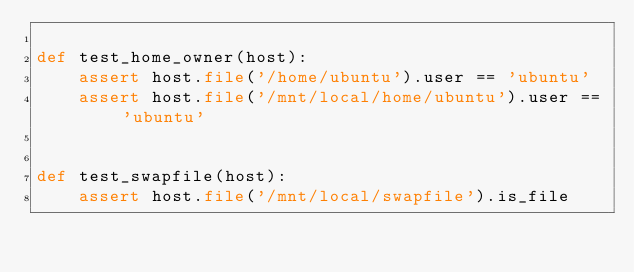Convert code to text. <code><loc_0><loc_0><loc_500><loc_500><_Python_>
def test_home_owner(host):
    assert host.file('/home/ubuntu').user == 'ubuntu'
    assert host.file('/mnt/local/home/ubuntu').user == 'ubuntu'


def test_swapfile(host):
    assert host.file('/mnt/local/swapfile').is_file
</code> 